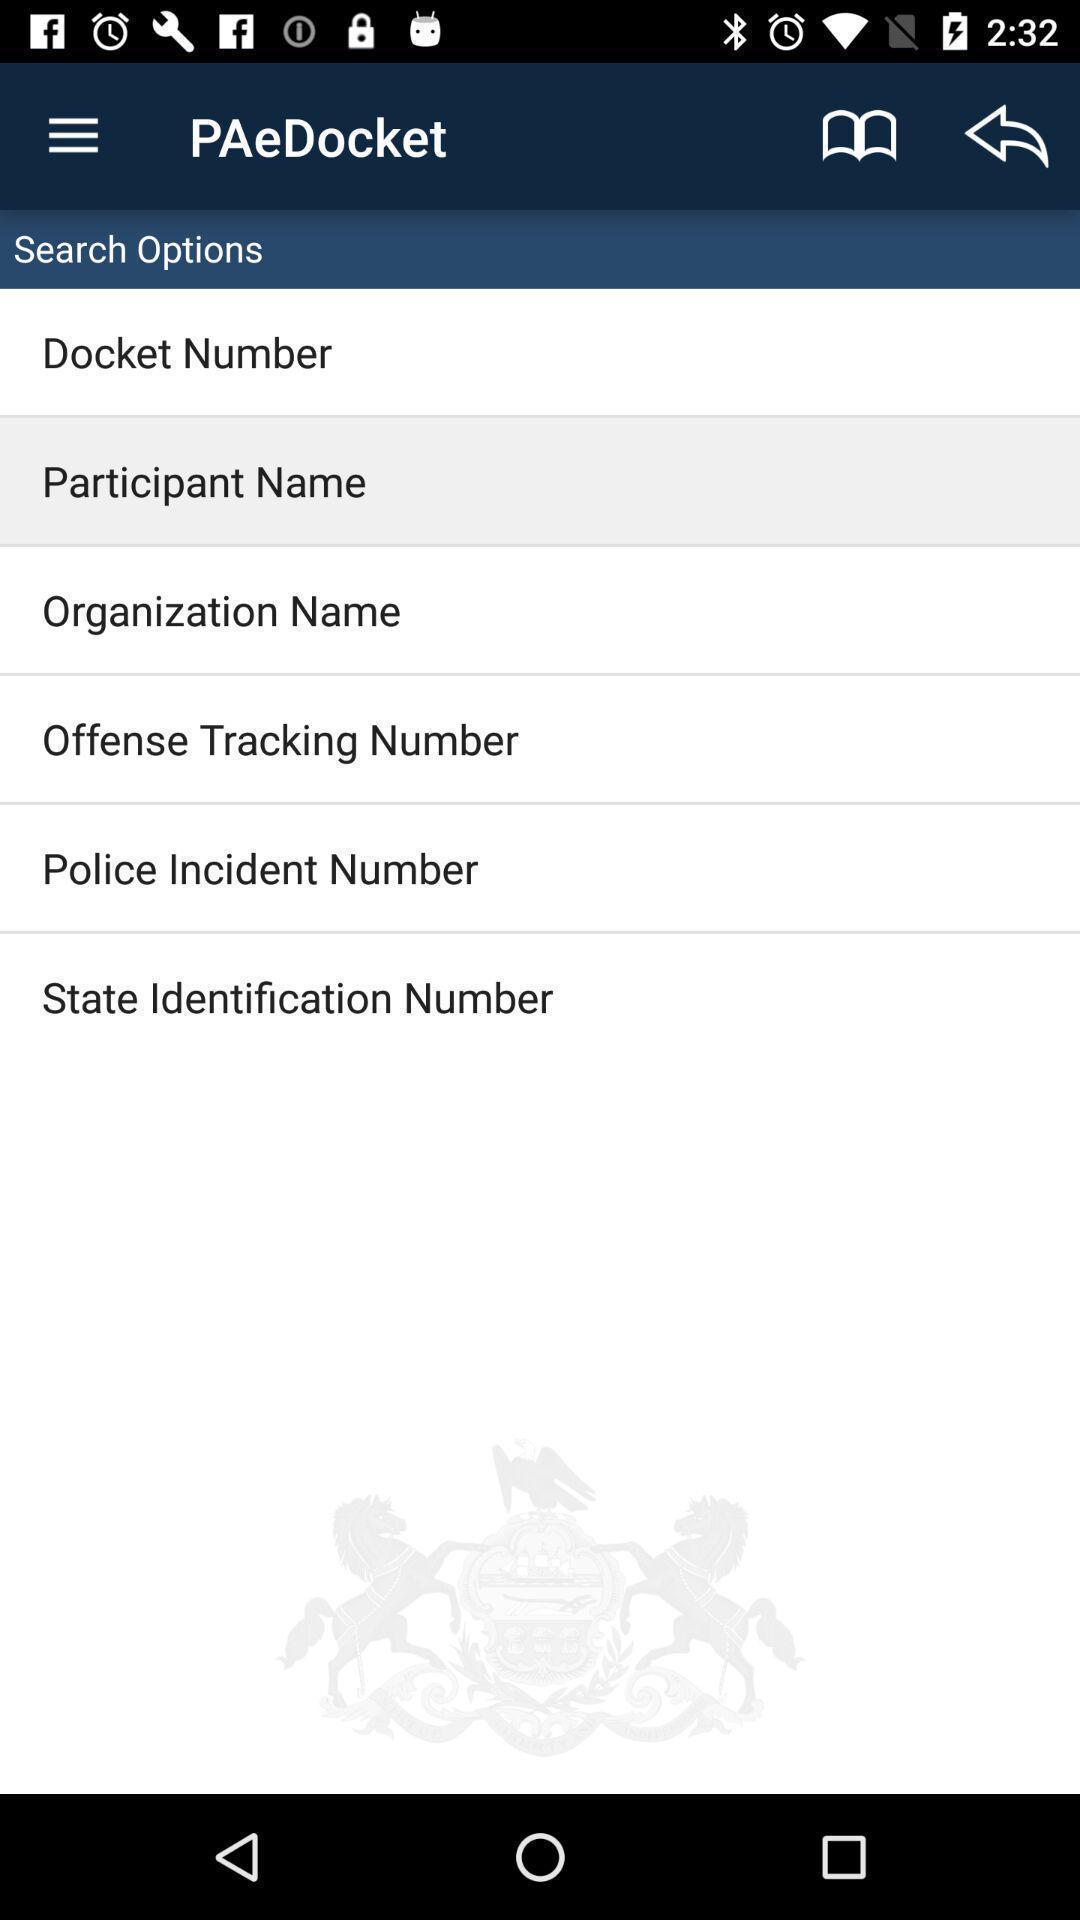Summarize the main components in this picture. Screen showing various search options. 